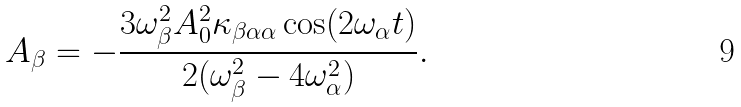Convert formula to latex. <formula><loc_0><loc_0><loc_500><loc_500>A _ { \beta } = - \frac { 3 \omega _ { \beta } ^ { 2 } A _ { 0 } ^ { 2 } \kappa _ { \beta \alpha \alpha } \cos ( 2 \omega _ { \alpha } t ) } { 2 ( \omega _ { \beta } ^ { 2 } - 4 \omega _ { \alpha } ^ { 2 } ) } .</formula> 